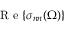<formula> <loc_0><loc_0><loc_500><loc_500>R e { \left \{ \sigma _ { n n } ( \Omega ) \right \} }</formula> 